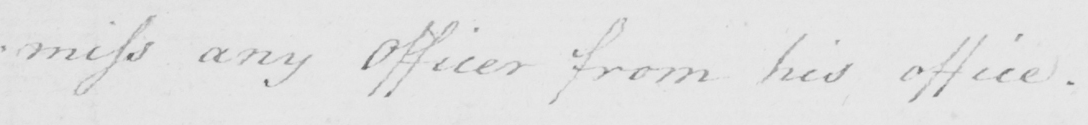Please provide the text content of this handwritten line. : miss any Officer from his office . 